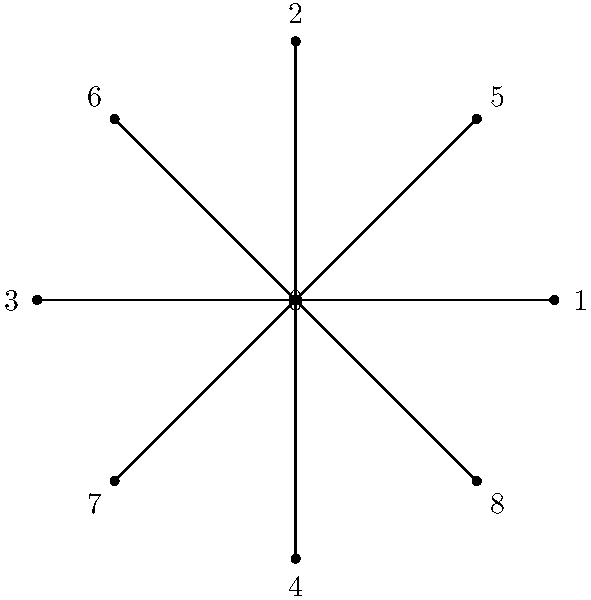In the star-shaped network above, which node serves as the central hub, weaving together the threads of influence like a master storyteller crafting a narrative tapestry? How does this node's position reflect the concept of degree centrality in network analysis? To answer this question, let's break down the concept of degree centrality and relate it to our star-shaped network:

1. Degree centrality is a measure of a node's connectedness within a network. It is calculated by counting the number of direct connections (edges) a node has to other nodes.

2. In our star-shaped network, we can observe that:
   - Node 0 is at the center and connected to all other nodes.
   - All other nodes (1-8) are only connected to Node 0.

3. Let's count the connections for each node:
   - Node 0: 8 connections
   - Nodes 1-8: 1 connection each

4. Node 0 has the highest degree centrality, making it the central hub of the network.

5. This star topology reflects a common storytelling structure where a central theme or character (Node 0) connects various plot points, characters, or ideas (Nodes 1-8).

6. Just as a skilled podcaster or storyteller weaves together different elements through a central narrative thread, Node 0 serves as the focal point that ties all other nodes together in this network.

Therefore, Node 0 is the central hub, demonstrating the highest degree centrality and acting as the narrative core of this network structure.
Answer: Node 0 